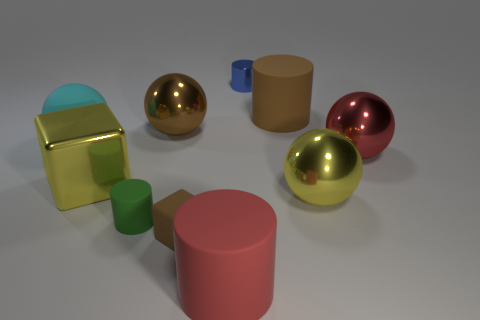Subtract all big cyan matte balls. How many balls are left? 3 Subtract all brown balls. How many balls are left? 3 Subtract all red blocks. Subtract all yellow balls. How many blocks are left? 2 Subtract all blue cylinders. How many cyan cubes are left? 0 Add 1 brown rubber cylinders. How many brown rubber cylinders are left? 2 Add 7 yellow objects. How many yellow objects exist? 9 Subtract 1 cyan balls. How many objects are left? 9 Subtract all blocks. How many objects are left? 8 Subtract 1 blocks. How many blocks are left? 1 Subtract all yellow things. Subtract all brown metal things. How many objects are left? 7 